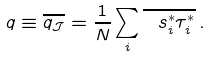<formula> <loc_0><loc_0><loc_500><loc_500>q \equiv \overline { q _ { \mathcal { J } } } = \frac { 1 } { N } \sum _ { i } \overline { \ s _ { i } ^ { * } \tau _ { i } ^ { * } } \, .</formula> 